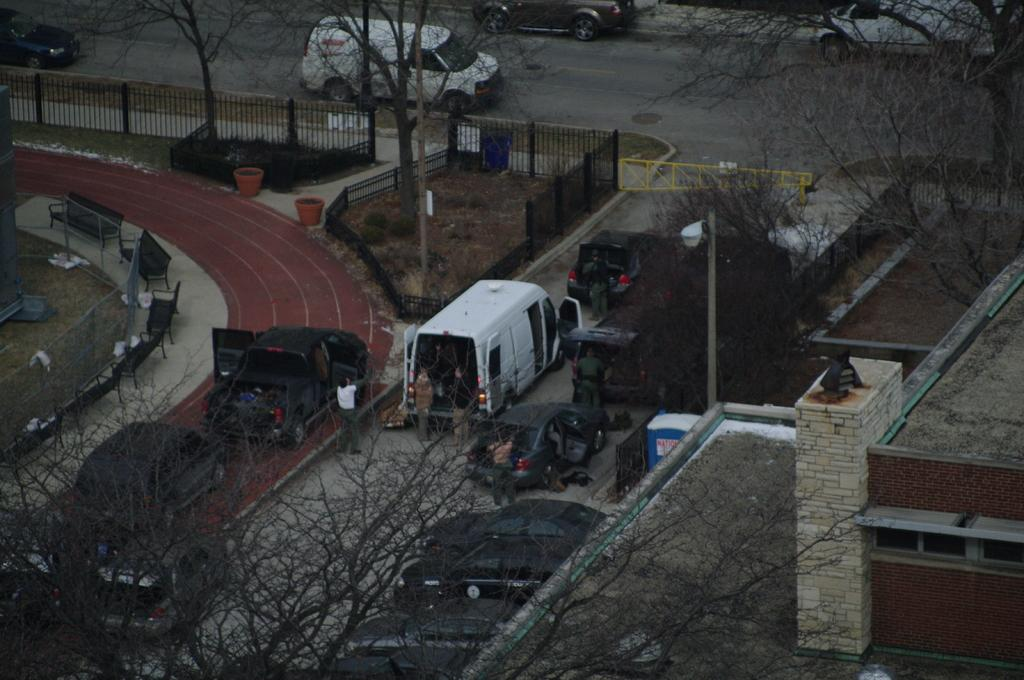What types of objects can be seen in the image? There are vehicles, a group of people, benches, grass, a wire fence, a pole, a light, iron grilles, and trees in the image. Can you describe the people in the image? There is a group of people standing in the image. What type of surface is visible in the image? There is grass in the image. What kind of barrier is present in the image? There is a wire fence in the image. What is attached to the pole in the image? There is a light attached to the pole in the image. What type of star can be seen in the image? There is no star present in the image. Is there a fight happening between the people in the image? There is no indication of a fight in the image; the people are simply standing. 